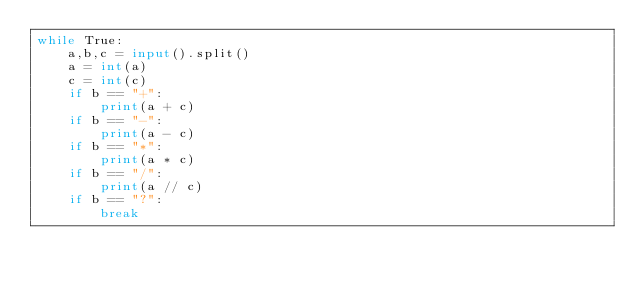Convert code to text. <code><loc_0><loc_0><loc_500><loc_500><_Python_>while True:
    a,b,c = input().split()
    a = int(a)
    c = int(c)
    if b == "+":
        print(a + c)
    if b == "-":
        print(a - c)
    if b == "*":
        print(a * c)
    if b == "/":
        print(a // c)
    if b == "?":
        break
</code> 